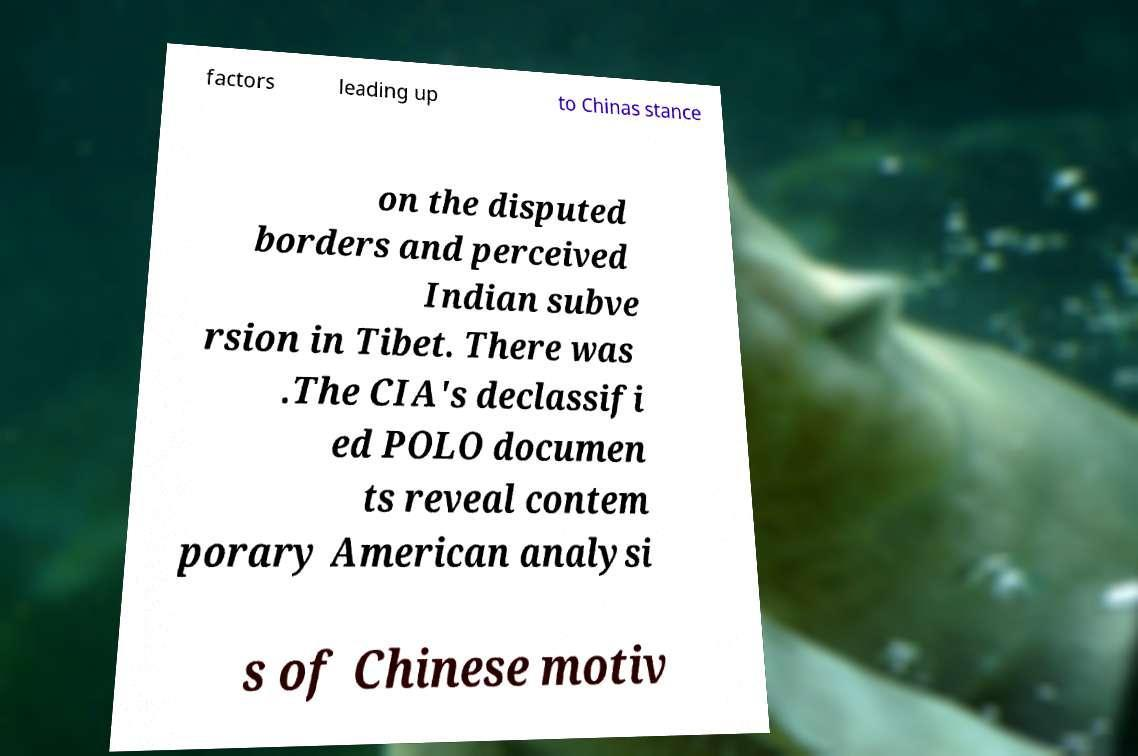I need the written content from this picture converted into text. Can you do that? factors leading up to Chinas stance on the disputed borders and perceived Indian subve rsion in Tibet. There was .The CIA's declassifi ed POLO documen ts reveal contem porary American analysi s of Chinese motiv 